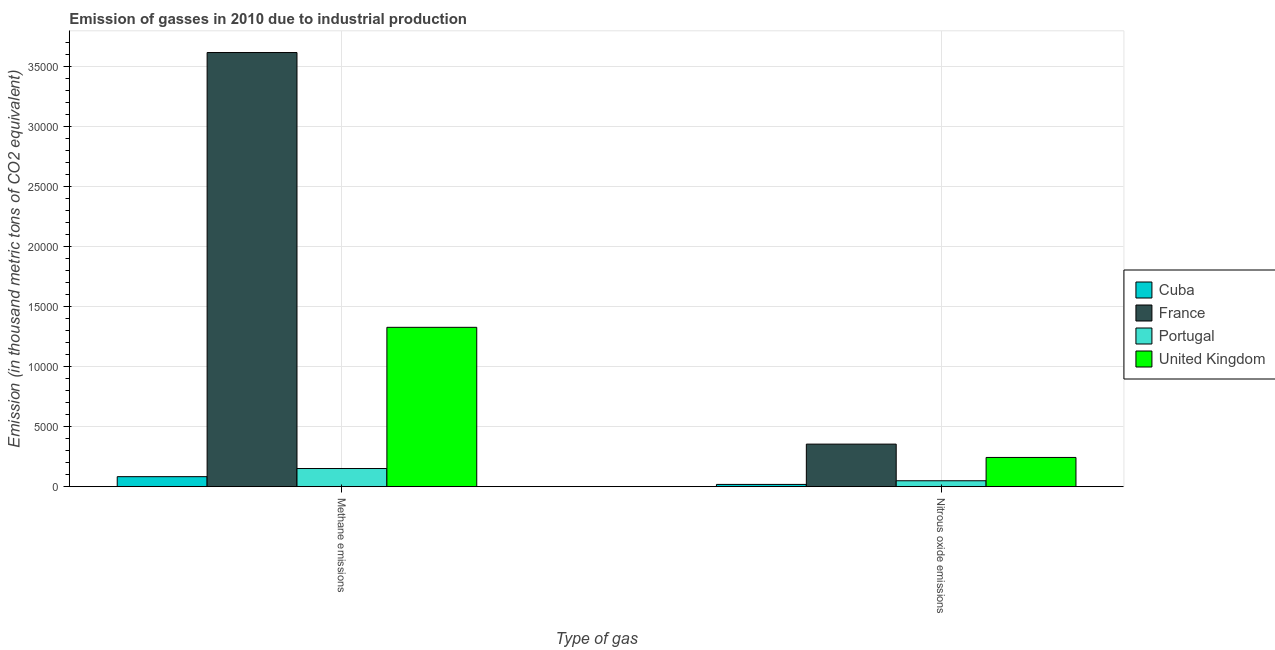How many different coloured bars are there?
Make the answer very short. 4. Are the number of bars on each tick of the X-axis equal?
Provide a short and direct response. Yes. How many bars are there on the 2nd tick from the right?
Your answer should be compact. 4. What is the label of the 1st group of bars from the left?
Ensure brevity in your answer.  Methane emissions. What is the amount of methane emissions in Cuba?
Offer a very short reply. 834.7. Across all countries, what is the maximum amount of methane emissions?
Make the answer very short. 3.61e+04. Across all countries, what is the minimum amount of nitrous oxide emissions?
Your answer should be compact. 189.6. In which country was the amount of nitrous oxide emissions maximum?
Your answer should be compact. France. In which country was the amount of methane emissions minimum?
Offer a very short reply. Cuba. What is the total amount of methane emissions in the graph?
Provide a succinct answer. 5.17e+04. What is the difference between the amount of nitrous oxide emissions in Cuba and that in United Kingdom?
Provide a short and direct response. -2243.6. What is the difference between the amount of methane emissions in Cuba and the amount of nitrous oxide emissions in United Kingdom?
Your answer should be compact. -1598.5. What is the average amount of nitrous oxide emissions per country?
Provide a short and direct response. 1664.67. What is the difference between the amount of nitrous oxide emissions and amount of methane emissions in United Kingdom?
Offer a very short reply. -1.08e+04. In how many countries, is the amount of methane emissions greater than 27000 thousand metric tons?
Keep it short and to the point. 1. What is the ratio of the amount of nitrous oxide emissions in France to that in Cuba?
Provide a succinct answer. 18.68. What does the 1st bar from the right in Nitrous oxide emissions represents?
Ensure brevity in your answer.  United Kingdom. Are all the bars in the graph horizontal?
Your answer should be very brief. No. How many countries are there in the graph?
Your answer should be very brief. 4. What is the difference between two consecutive major ticks on the Y-axis?
Make the answer very short. 5000. Does the graph contain any zero values?
Your response must be concise. No. How are the legend labels stacked?
Ensure brevity in your answer.  Vertical. What is the title of the graph?
Offer a very short reply. Emission of gasses in 2010 due to industrial production. What is the label or title of the X-axis?
Provide a short and direct response. Type of gas. What is the label or title of the Y-axis?
Your answer should be compact. Emission (in thousand metric tons of CO2 equivalent). What is the Emission (in thousand metric tons of CO2 equivalent) in Cuba in Methane emissions?
Make the answer very short. 834.7. What is the Emission (in thousand metric tons of CO2 equivalent) of France in Methane emissions?
Give a very brief answer. 3.61e+04. What is the Emission (in thousand metric tons of CO2 equivalent) of Portugal in Methane emissions?
Your response must be concise. 1511.5. What is the Emission (in thousand metric tons of CO2 equivalent) in United Kingdom in Methane emissions?
Your answer should be compact. 1.33e+04. What is the Emission (in thousand metric tons of CO2 equivalent) in Cuba in Nitrous oxide emissions?
Your answer should be very brief. 189.6. What is the Emission (in thousand metric tons of CO2 equivalent) in France in Nitrous oxide emissions?
Provide a short and direct response. 3541.9. What is the Emission (in thousand metric tons of CO2 equivalent) of Portugal in Nitrous oxide emissions?
Offer a very short reply. 494. What is the Emission (in thousand metric tons of CO2 equivalent) in United Kingdom in Nitrous oxide emissions?
Keep it short and to the point. 2433.2. Across all Type of gas, what is the maximum Emission (in thousand metric tons of CO2 equivalent) in Cuba?
Make the answer very short. 834.7. Across all Type of gas, what is the maximum Emission (in thousand metric tons of CO2 equivalent) of France?
Make the answer very short. 3.61e+04. Across all Type of gas, what is the maximum Emission (in thousand metric tons of CO2 equivalent) of Portugal?
Ensure brevity in your answer.  1511.5. Across all Type of gas, what is the maximum Emission (in thousand metric tons of CO2 equivalent) of United Kingdom?
Ensure brevity in your answer.  1.33e+04. Across all Type of gas, what is the minimum Emission (in thousand metric tons of CO2 equivalent) in Cuba?
Provide a short and direct response. 189.6. Across all Type of gas, what is the minimum Emission (in thousand metric tons of CO2 equivalent) of France?
Give a very brief answer. 3541.9. Across all Type of gas, what is the minimum Emission (in thousand metric tons of CO2 equivalent) in Portugal?
Provide a short and direct response. 494. Across all Type of gas, what is the minimum Emission (in thousand metric tons of CO2 equivalent) of United Kingdom?
Provide a succinct answer. 2433.2. What is the total Emission (in thousand metric tons of CO2 equivalent) of Cuba in the graph?
Your response must be concise. 1024.3. What is the total Emission (in thousand metric tons of CO2 equivalent) in France in the graph?
Give a very brief answer. 3.97e+04. What is the total Emission (in thousand metric tons of CO2 equivalent) in Portugal in the graph?
Offer a terse response. 2005.5. What is the total Emission (in thousand metric tons of CO2 equivalent) in United Kingdom in the graph?
Your response must be concise. 1.57e+04. What is the difference between the Emission (in thousand metric tons of CO2 equivalent) in Cuba in Methane emissions and that in Nitrous oxide emissions?
Offer a terse response. 645.1. What is the difference between the Emission (in thousand metric tons of CO2 equivalent) in France in Methane emissions and that in Nitrous oxide emissions?
Keep it short and to the point. 3.26e+04. What is the difference between the Emission (in thousand metric tons of CO2 equivalent) of Portugal in Methane emissions and that in Nitrous oxide emissions?
Provide a short and direct response. 1017.5. What is the difference between the Emission (in thousand metric tons of CO2 equivalent) in United Kingdom in Methane emissions and that in Nitrous oxide emissions?
Provide a succinct answer. 1.08e+04. What is the difference between the Emission (in thousand metric tons of CO2 equivalent) in Cuba in Methane emissions and the Emission (in thousand metric tons of CO2 equivalent) in France in Nitrous oxide emissions?
Your answer should be compact. -2707.2. What is the difference between the Emission (in thousand metric tons of CO2 equivalent) in Cuba in Methane emissions and the Emission (in thousand metric tons of CO2 equivalent) in Portugal in Nitrous oxide emissions?
Keep it short and to the point. 340.7. What is the difference between the Emission (in thousand metric tons of CO2 equivalent) of Cuba in Methane emissions and the Emission (in thousand metric tons of CO2 equivalent) of United Kingdom in Nitrous oxide emissions?
Your answer should be compact. -1598.5. What is the difference between the Emission (in thousand metric tons of CO2 equivalent) of France in Methane emissions and the Emission (in thousand metric tons of CO2 equivalent) of Portugal in Nitrous oxide emissions?
Offer a terse response. 3.56e+04. What is the difference between the Emission (in thousand metric tons of CO2 equivalent) of France in Methane emissions and the Emission (in thousand metric tons of CO2 equivalent) of United Kingdom in Nitrous oxide emissions?
Provide a succinct answer. 3.37e+04. What is the difference between the Emission (in thousand metric tons of CO2 equivalent) in Portugal in Methane emissions and the Emission (in thousand metric tons of CO2 equivalent) in United Kingdom in Nitrous oxide emissions?
Offer a very short reply. -921.7. What is the average Emission (in thousand metric tons of CO2 equivalent) in Cuba per Type of gas?
Provide a succinct answer. 512.15. What is the average Emission (in thousand metric tons of CO2 equivalent) of France per Type of gas?
Your answer should be very brief. 1.98e+04. What is the average Emission (in thousand metric tons of CO2 equivalent) in Portugal per Type of gas?
Your answer should be compact. 1002.75. What is the average Emission (in thousand metric tons of CO2 equivalent) of United Kingdom per Type of gas?
Provide a succinct answer. 7846.95. What is the difference between the Emission (in thousand metric tons of CO2 equivalent) in Cuba and Emission (in thousand metric tons of CO2 equivalent) in France in Methane emissions?
Your response must be concise. -3.53e+04. What is the difference between the Emission (in thousand metric tons of CO2 equivalent) of Cuba and Emission (in thousand metric tons of CO2 equivalent) of Portugal in Methane emissions?
Offer a very short reply. -676.8. What is the difference between the Emission (in thousand metric tons of CO2 equivalent) of Cuba and Emission (in thousand metric tons of CO2 equivalent) of United Kingdom in Methane emissions?
Give a very brief answer. -1.24e+04. What is the difference between the Emission (in thousand metric tons of CO2 equivalent) of France and Emission (in thousand metric tons of CO2 equivalent) of Portugal in Methane emissions?
Keep it short and to the point. 3.46e+04. What is the difference between the Emission (in thousand metric tons of CO2 equivalent) of France and Emission (in thousand metric tons of CO2 equivalent) of United Kingdom in Methane emissions?
Offer a very short reply. 2.29e+04. What is the difference between the Emission (in thousand metric tons of CO2 equivalent) in Portugal and Emission (in thousand metric tons of CO2 equivalent) in United Kingdom in Methane emissions?
Your answer should be very brief. -1.17e+04. What is the difference between the Emission (in thousand metric tons of CO2 equivalent) in Cuba and Emission (in thousand metric tons of CO2 equivalent) in France in Nitrous oxide emissions?
Offer a terse response. -3352.3. What is the difference between the Emission (in thousand metric tons of CO2 equivalent) in Cuba and Emission (in thousand metric tons of CO2 equivalent) in Portugal in Nitrous oxide emissions?
Your answer should be compact. -304.4. What is the difference between the Emission (in thousand metric tons of CO2 equivalent) in Cuba and Emission (in thousand metric tons of CO2 equivalent) in United Kingdom in Nitrous oxide emissions?
Make the answer very short. -2243.6. What is the difference between the Emission (in thousand metric tons of CO2 equivalent) of France and Emission (in thousand metric tons of CO2 equivalent) of Portugal in Nitrous oxide emissions?
Make the answer very short. 3047.9. What is the difference between the Emission (in thousand metric tons of CO2 equivalent) of France and Emission (in thousand metric tons of CO2 equivalent) of United Kingdom in Nitrous oxide emissions?
Your response must be concise. 1108.7. What is the difference between the Emission (in thousand metric tons of CO2 equivalent) of Portugal and Emission (in thousand metric tons of CO2 equivalent) of United Kingdom in Nitrous oxide emissions?
Provide a succinct answer. -1939.2. What is the ratio of the Emission (in thousand metric tons of CO2 equivalent) in Cuba in Methane emissions to that in Nitrous oxide emissions?
Provide a short and direct response. 4.4. What is the ratio of the Emission (in thousand metric tons of CO2 equivalent) in France in Methane emissions to that in Nitrous oxide emissions?
Provide a succinct answer. 10.2. What is the ratio of the Emission (in thousand metric tons of CO2 equivalent) of Portugal in Methane emissions to that in Nitrous oxide emissions?
Provide a short and direct response. 3.06. What is the ratio of the Emission (in thousand metric tons of CO2 equivalent) in United Kingdom in Methane emissions to that in Nitrous oxide emissions?
Provide a succinct answer. 5.45. What is the difference between the highest and the second highest Emission (in thousand metric tons of CO2 equivalent) of Cuba?
Give a very brief answer. 645.1. What is the difference between the highest and the second highest Emission (in thousand metric tons of CO2 equivalent) in France?
Provide a succinct answer. 3.26e+04. What is the difference between the highest and the second highest Emission (in thousand metric tons of CO2 equivalent) in Portugal?
Offer a terse response. 1017.5. What is the difference between the highest and the second highest Emission (in thousand metric tons of CO2 equivalent) of United Kingdom?
Make the answer very short. 1.08e+04. What is the difference between the highest and the lowest Emission (in thousand metric tons of CO2 equivalent) in Cuba?
Ensure brevity in your answer.  645.1. What is the difference between the highest and the lowest Emission (in thousand metric tons of CO2 equivalent) in France?
Keep it short and to the point. 3.26e+04. What is the difference between the highest and the lowest Emission (in thousand metric tons of CO2 equivalent) in Portugal?
Keep it short and to the point. 1017.5. What is the difference between the highest and the lowest Emission (in thousand metric tons of CO2 equivalent) of United Kingdom?
Offer a very short reply. 1.08e+04. 